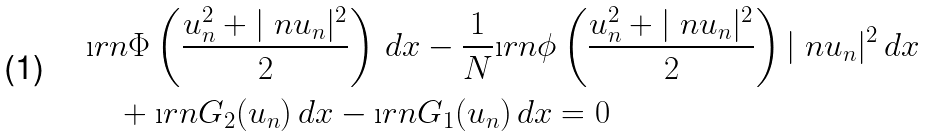<formula> <loc_0><loc_0><loc_500><loc_500>& \i r n \Phi \left ( \frac { u _ { n } ^ { 2 } + | \ n u _ { n } | ^ { 2 } } { 2 } \right ) \, d x - \frac { 1 } { N } \i r n \phi \left ( \frac { u _ { n } ^ { 2 } + | \ n u _ { n } | ^ { 2 } } { 2 } \right ) | \ n u _ { n } | ^ { 2 } \, d x \\ & \quad + \i r n G _ { 2 } ( u _ { n } ) \, d x - \i r n G _ { 1 } ( u _ { n } ) \, d x = 0</formula> 